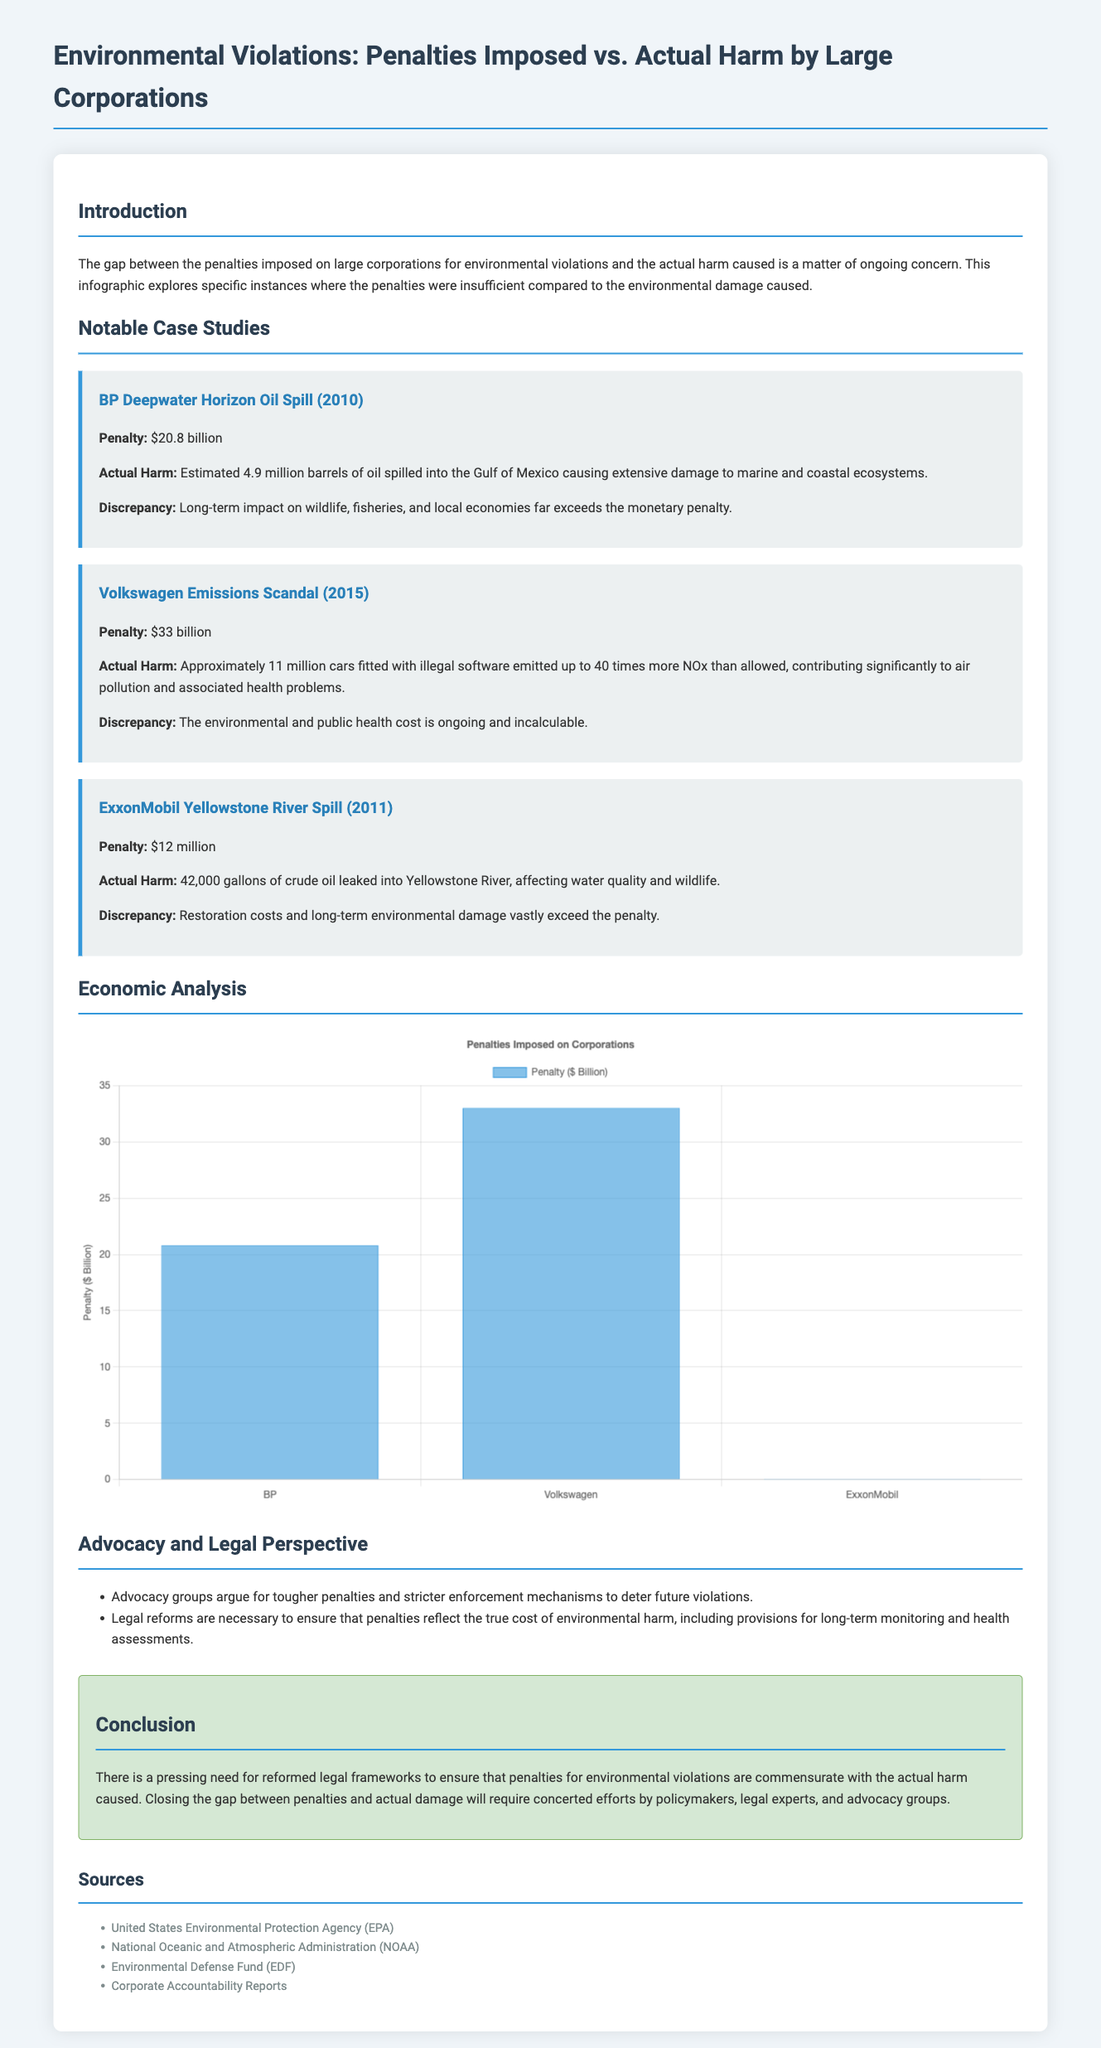What was the penalty for the BP Deepwater Horizon oil spill? The document states that the penalty for the BP Deepwater Horizon oil spill was $20.8 billion.
Answer: $20.8 billion How many barrels of oil were estimated to be spilled in the BP Deepwater Horizon oil spill? The document notes that approximately 4.9 million barrels of oil were spilled into the Gulf of Mexico.
Answer: 4.9 million barrels What was the total penalty assessed for the Volkswagen emissions scandal? According to the document, the penalty imposed for the Volkswagen emissions scandal was $33 billion.
Answer: $33 billion What environmental issue was associated with the ExxonMobil Yellowstone River spill? The ExxonMobil Yellowstone River spill affected water quality and wildlife as noted in the document.
Answer: Water quality and wildlife Which corporation had the highest penalty on the chart? The document indicates that Volkswagen had the highest penalty at $33 billion.
Answer: Volkswagen What is emphasized as a necessary measure in the legal perspective section of the document? The legal perspective section emphasizes the need for tougher penalties and stricter enforcement mechanisms.
Answer: Tougher penalties What type of visual representation is used to display the penalties imposed on corporations? The document uses a bar chart to represent the penalties imposed on corporations.
Answer: Bar chart Which case study mentions ongoing public health costs? The Volkswagen emissions scandal case study mentions ongoing public health costs.
Answer: Volkswagen emissions scandal What does the conclusion state is needed regarding penalties for environmental violations? The conclusion states that there is a need for reformed legal frameworks to ensure penalties match actual harm.
Answer: Reformed legal frameworks 